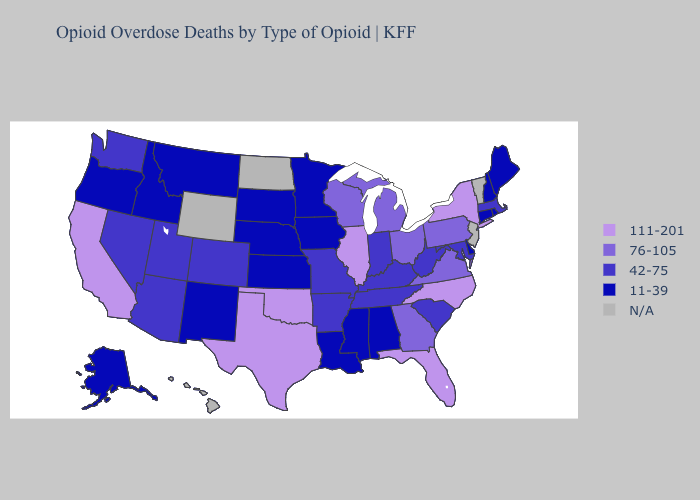What is the value of Wisconsin?
Short answer required. 76-105. What is the lowest value in the MidWest?
Keep it brief. 11-39. What is the lowest value in states that border Arkansas?
Concise answer only. 11-39. What is the lowest value in the USA?
Be succinct. 11-39. Does the map have missing data?
Short answer required. Yes. What is the highest value in the MidWest ?
Answer briefly. 111-201. Which states hav the highest value in the MidWest?
Answer briefly. Illinois. Name the states that have a value in the range 111-201?
Concise answer only. California, Florida, Illinois, New York, North Carolina, Oklahoma, Texas. Does Colorado have the lowest value in the West?
Short answer required. No. Among the states that border New Mexico , which have the highest value?
Answer briefly. Oklahoma, Texas. Name the states that have a value in the range 111-201?
Write a very short answer. California, Florida, Illinois, New York, North Carolina, Oklahoma, Texas. What is the value of New Jersey?
Be succinct. N/A. What is the value of Oklahoma?
Answer briefly. 111-201. What is the lowest value in the Northeast?
Write a very short answer. 11-39. 